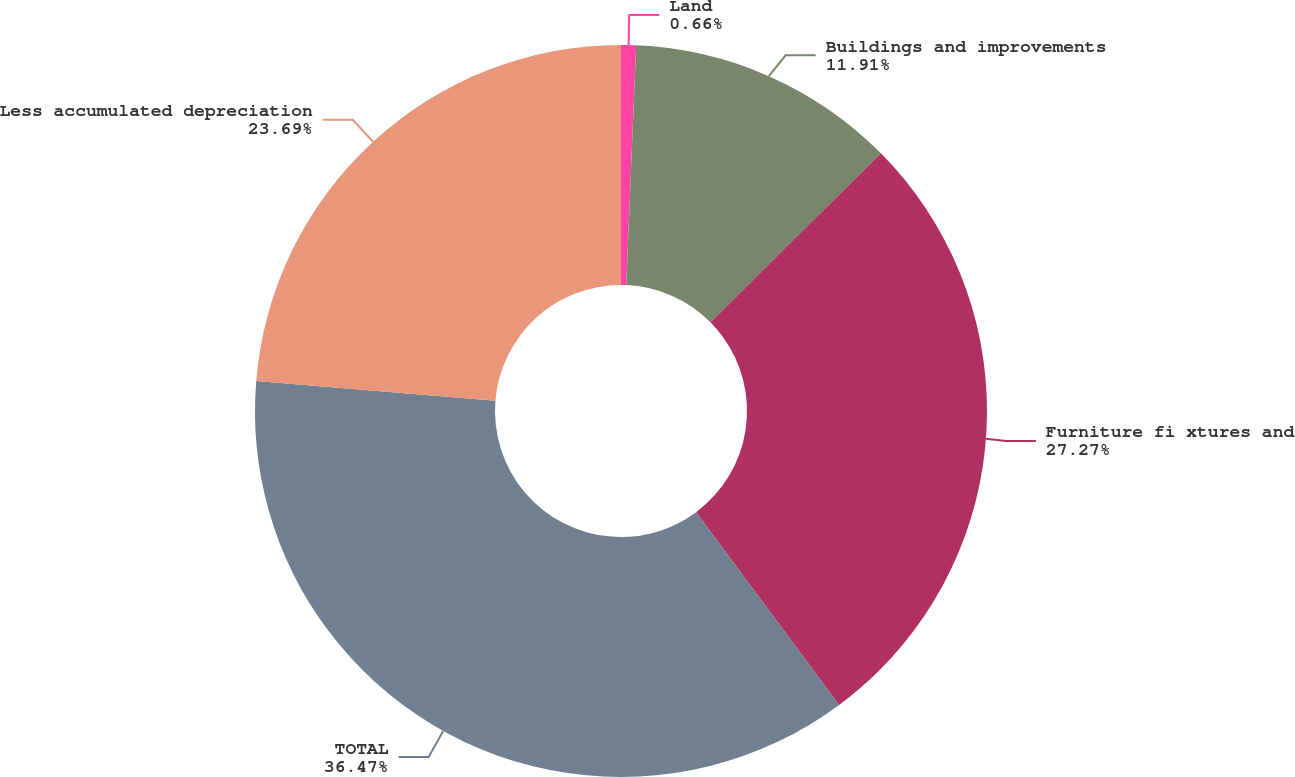Convert chart to OTSL. <chart><loc_0><loc_0><loc_500><loc_500><pie_chart><fcel>Land<fcel>Buildings and improvements<fcel>Furniture fi xtures and<fcel>TOTAL<fcel>Less accumulated depreciation<nl><fcel>0.66%<fcel>11.91%<fcel>27.27%<fcel>36.47%<fcel>23.69%<nl></chart> 